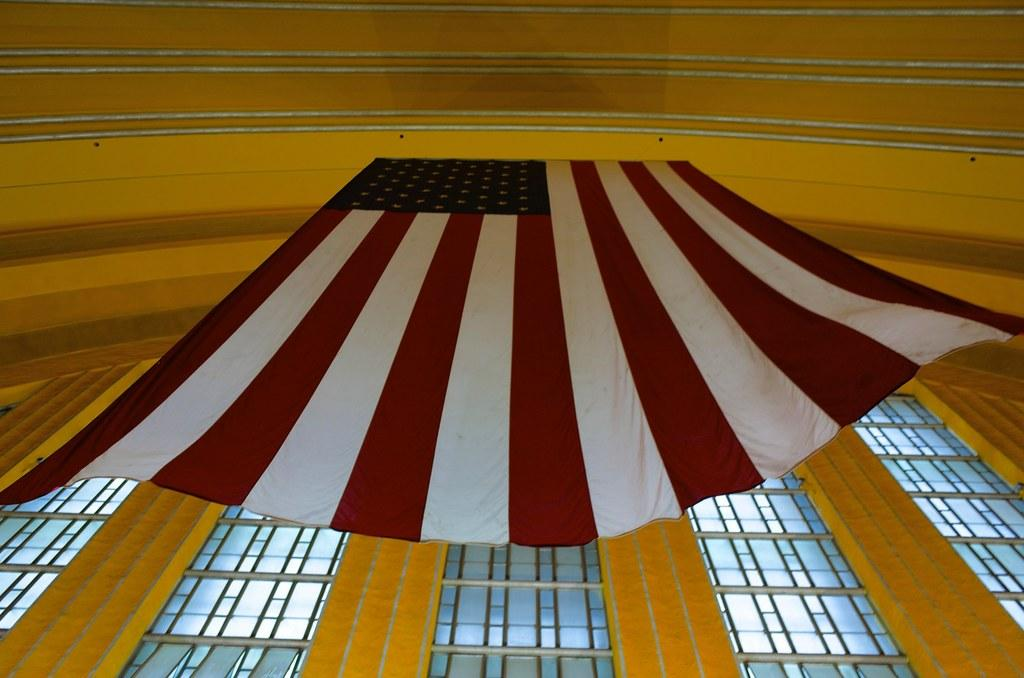What type of structure can be seen in the image? There is a wall in the image. What material might the windows in the image be made of? The windows in the image are made of glass. Where is the flag located in the image? The flag is in the center of the image. Can you see any giants walking along the seashore in the image? There are no giants or seashore present in the image; it features a wall, glass windows, and a flag. 